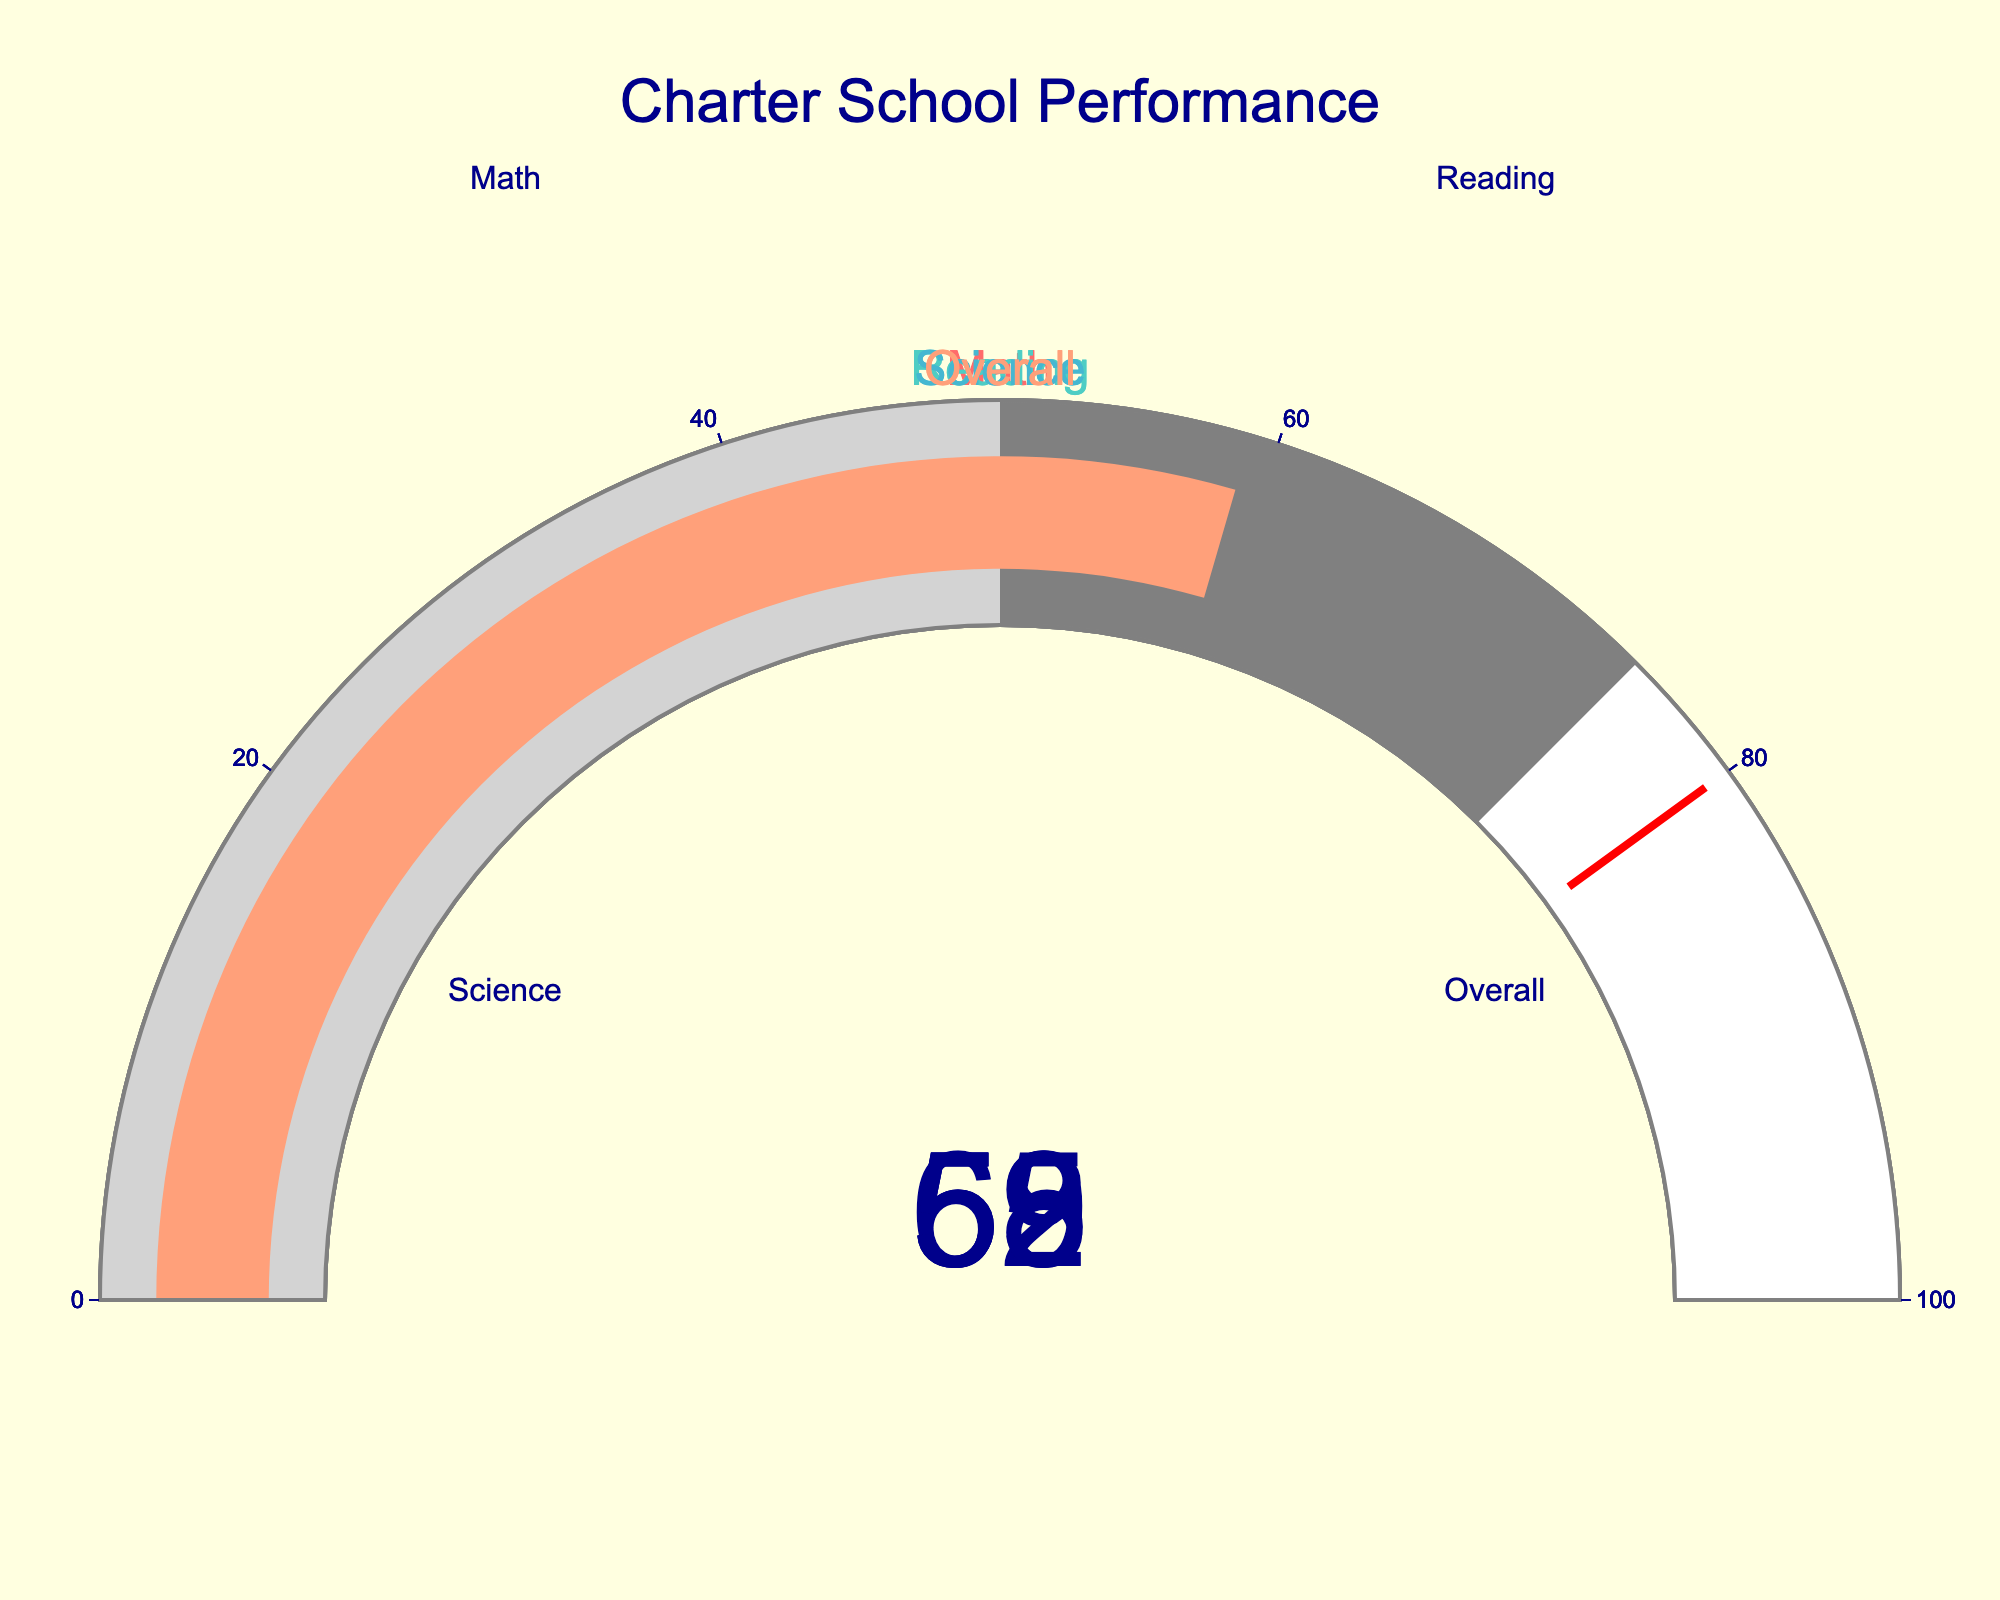Which subject has the highest percentage of students performing at or above grade level? By looking at each gauge, compare the percentages and identify Math as having the highest value, which is 62.
Answer: Math What is the overall percentage of students performing at or above grade level? Refer to the gauge labeled "Overall" to find the percentage, which is displayed as 59.
Answer: 59 How much lower is the Science performance compared to Math? Subtract the Science percentage (55) from the Math percentage (62) to find the difference: 62 - 55 = 7.
Answer: 7 What is the average percentage of students performing at or above grade level across all subjects (Math, Reading, Science, Overall)? Sum the percentages for all subjects: 62 + 58 + 55 + 59 = 234. Divide by the number of subjects (4): 234 / 4 = 58.5.
Answer: 58.5 Which subject has the lowest performance percentage? By examining each gauge, identify Science as having the lowest percentage, which is 55.
Answer: Science Is the overall performance above or below the 60% mark? Refer to the "Overall" gauge and see that the percentage is 59, which is below 60.
Answer: Below By how much is the Reading performance greater than the Science performance? Subtract the Science percentage (55) from the Reading percentage (58) to find the difference: 58 - 55 = 3.
Answer: 3 If the goal is to have at least 75% of students performing at grade level, how many subjects currently meet this threshold? None of the gauges show percentages at or above 75. Thus, zero subjects meet this threshold.
Answer: 0 What's the combined percentage for Math and Reading performances? Add the percentages for Math (62) and Reading (58): 62 + 58 = 120.
Answer: 120 